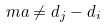Convert formula to latex. <formula><loc_0><loc_0><loc_500><loc_500>m a \neq d _ { j } - d _ { i }</formula> 